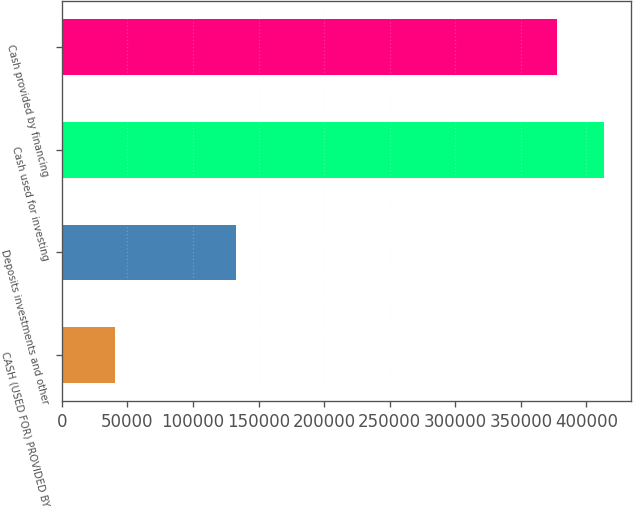Convert chart. <chart><loc_0><loc_0><loc_500><loc_500><bar_chart><fcel>CASH (USED FOR) PROVIDED BY<fcel>Deposits investments and other<fcel>Cash used for investing<fcel>Cash provided by financing<nl><fcel>40211<fcel>133040<fcel>413722<fcel>377861<nl></chart> 